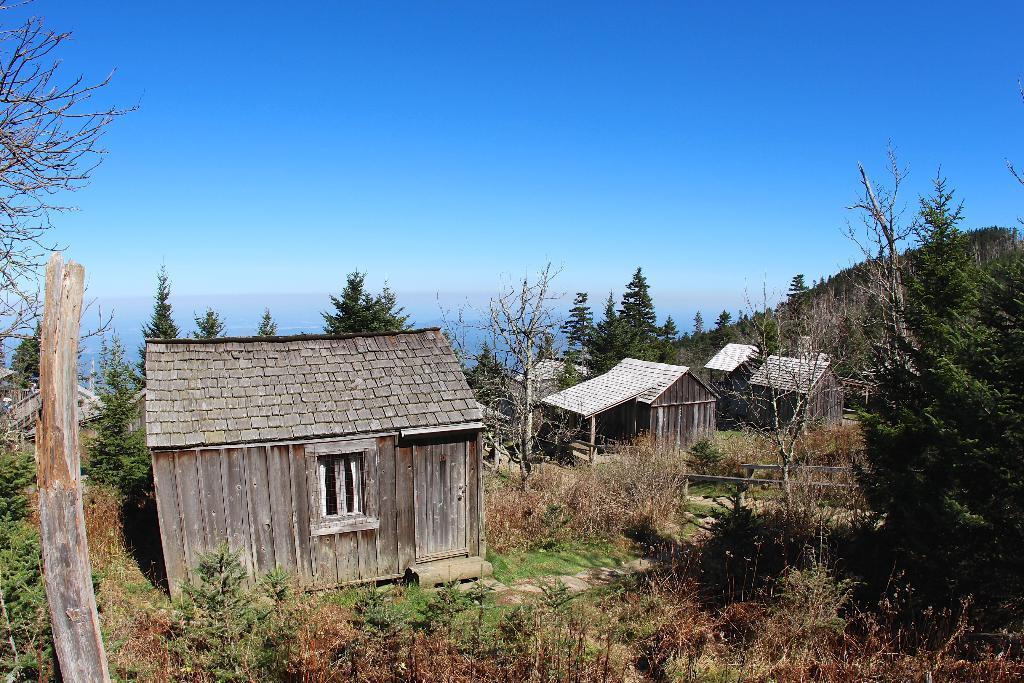Describe this image in one or two sentences. In the picture we can see many plants, grass, on the path and we can see some wooden houses, huts and near to it, we can see some trees and behind we can see some hills with trees and sky which is blue in color. 